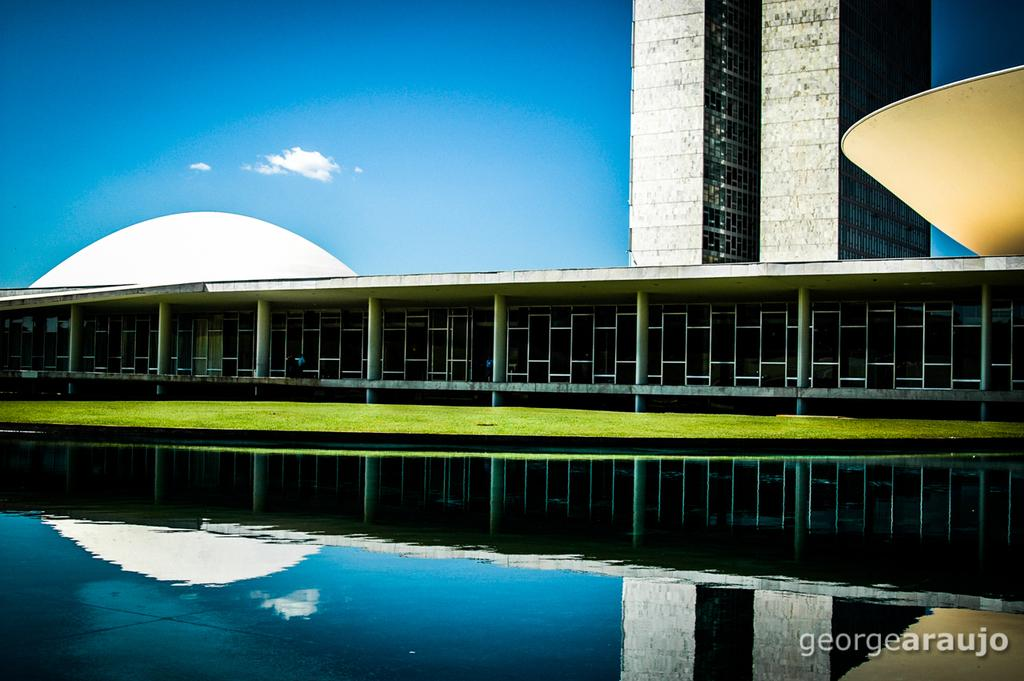What is present in the front of the image? There is water in the front of the image. What can be seen in the background of the image? There is grass, buildings, clouds in the sky, and the sky itself visible in the background of the image. Can you describe the natural environment in the image? The natural environment includes grass and water. What is the watermark in the image? The watermark is in the bottom right corner of the image. What route is the car taking in the image? There is no car present in the image, so it is not possible to determine a route. What type of trail can be seen in the image? There is no trail visible in the image; it features water, grass, buildings, and clouds in the sky. 